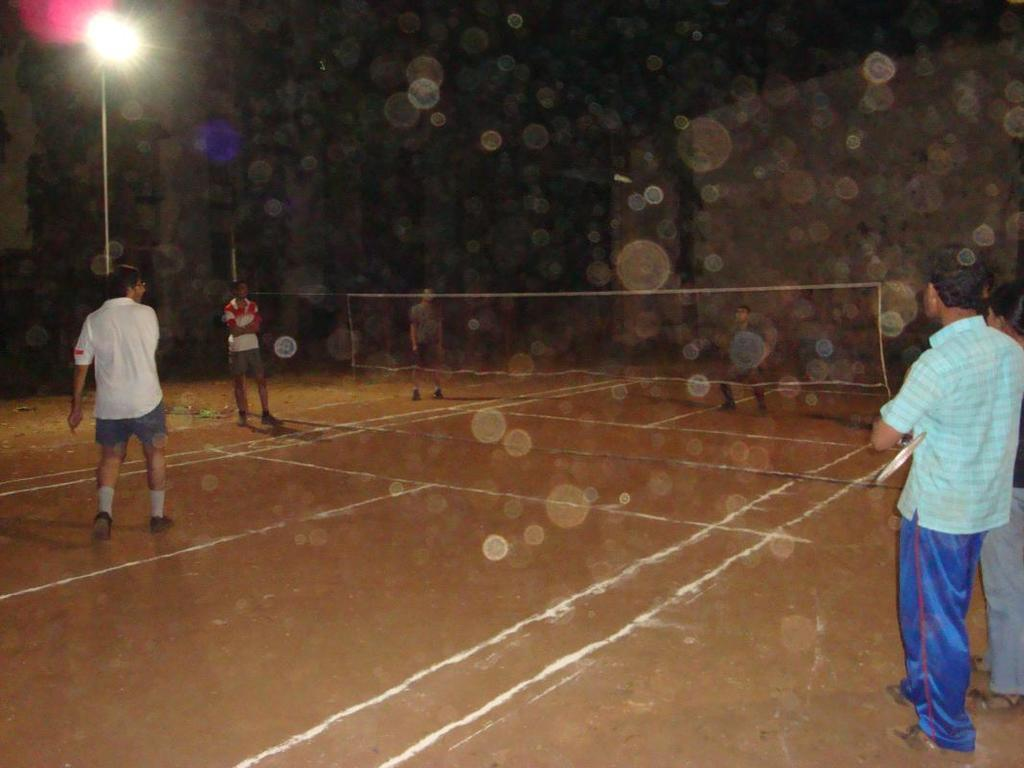What structure is located on the left side corner of the image? There is a street light on the left side corner of the image. What activity are the men engaged in on the ground in the image? The men are playing volleyball on the ground in the image. What color is the silver coughing in the image? There is no silver or coughing present in the image. What type of question is being asked in the image? There is no question being asked in the image. 